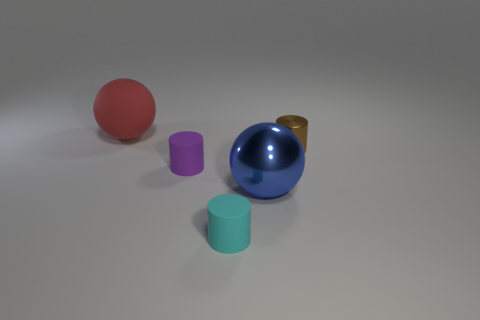Subtract all matte cylinders. How many cylinders are left? 1 Subtract all purple cylinders. How many cylinders are left? 2 Add 4 big blue objects. How many objects exist? 9 Subtract all spheres. How many objects are left? 3 Subtract 2 cylinders. How many cylinders are left? 1 Subtract all rubber objects. Subtract all cyan rubber things. How many objects are left? 1 Add 3 large red rubber spheres. How many large red rubber spheres are left? 4 Add 1 small brown matte balls. How many small brown matte balls exist? 1 Subtract 0 brown balls. How many objects are left? 5 Subtract all brown cylinders. Subtract all gray cubes. How many cylinders are left? 2 